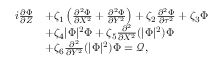<formula> <loc_0><loc_0><loc_500><loc_500>\begin{array} { r l } { i \frac { \partial \Phi } { \partial Z } } & { + \zeta _ { 1 } \left ( \frac { \partial ^ { 2 } \Phi } { \partial X ^ { 2 } } + \frac { \partial ^ { 2 } \Phi } { \partial Y ^ { 2 } } \right ) + \zeta _ { 2 } \frac { \partial ^ { 2 } \Phi } { \partial \tau ^ { 2 } } + \zeta _ { 3 } \Phi } \\ & { + \zeta _ { 4 } | \Phi | ^ { 2 } \Phi + \zeta _ { 5 } \frac { \partial ^ { 2 } } { \partial X ^ { 2 } } ( | \Phi | ^ { 2 } ) \Phi } \\ & { + \zeta _ { 6 } \frac { \partial ^ { 2 } } { \partial Y ^ { 2 } } ( | \Phi | ^ { 2 } ) \Phi = \mathcal { Q } , } \end{array}</formula> 